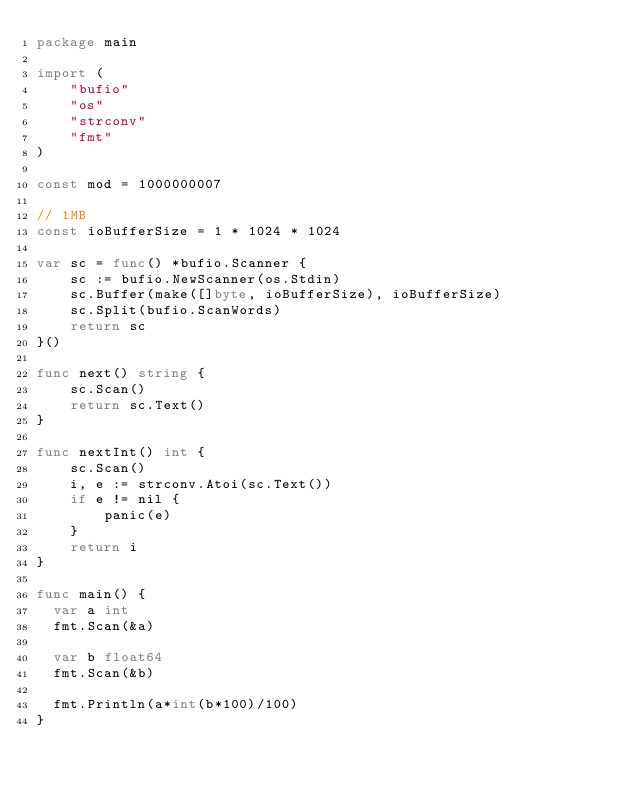<code> <loc_0><loc_0><loc_500><loc_500><_Go_>package main

import (
	"bufio"
	"os"
	"strconv"
    "fmt"
)

const mod = 1000000007

// 1MB
const ioBufferSize = 1 * 1024 * 1024

var sc = func() *bufio.Scanner {
	sc := bufio.NewScanner(os.Stdin)
	sc.Buffer(make([]byte, ioBufferSize), ioBufferSize)
	sc.Split(bufio.ScanWords)
	return sc
}()

func next() string {
	sc.Scan()
	return sc.Text()
}

func nextInt() int {
	sc.Scan()
	i, e := strconv.Atoi(sc.Text())
	if e != nil {
		panic(e)
	}
	return i
}

func main() {
  var a int
  fmt.Scan(&a)
  
  var b float64
  fmt.Scan(&b)
  
  fmt.Println(a*int(b*100)/100)
}</code> 